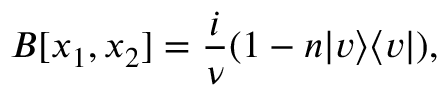Convert formula to latex. <formula><loc_0><loc_0><loc_500><loc_500>B [ x _ { 1 } , x _ { 2 } ] = \frac { i } { \nu } ( 1 - n | v \rangle \langle v | ) ,</formula> 